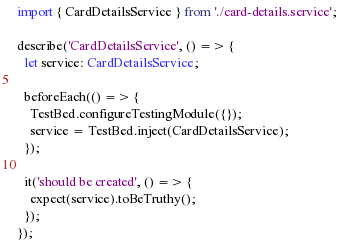<code> <loc_0><loc_0><loc_500><loc_500><_TypeScript_>
import { CardDetailsService } from './card-details.service';

describe('CardDetailsService', () => {
  let service: CardDetailsService;

  beforeEach(() => {
    TestBed.configureTestingModule({});
    service = TestBed.inject(CardDetailsService);
  });

  it('should be created', () => {
    expect(service).toBeTruthy();
  });
});
</code> 